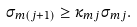<formula> <loc_0><loc_0><loc_500><loc_500>\sigma _ { m ( j + 1 ) } \geq \kappa _ { m j } \sigma _ { m j } .</formula> 